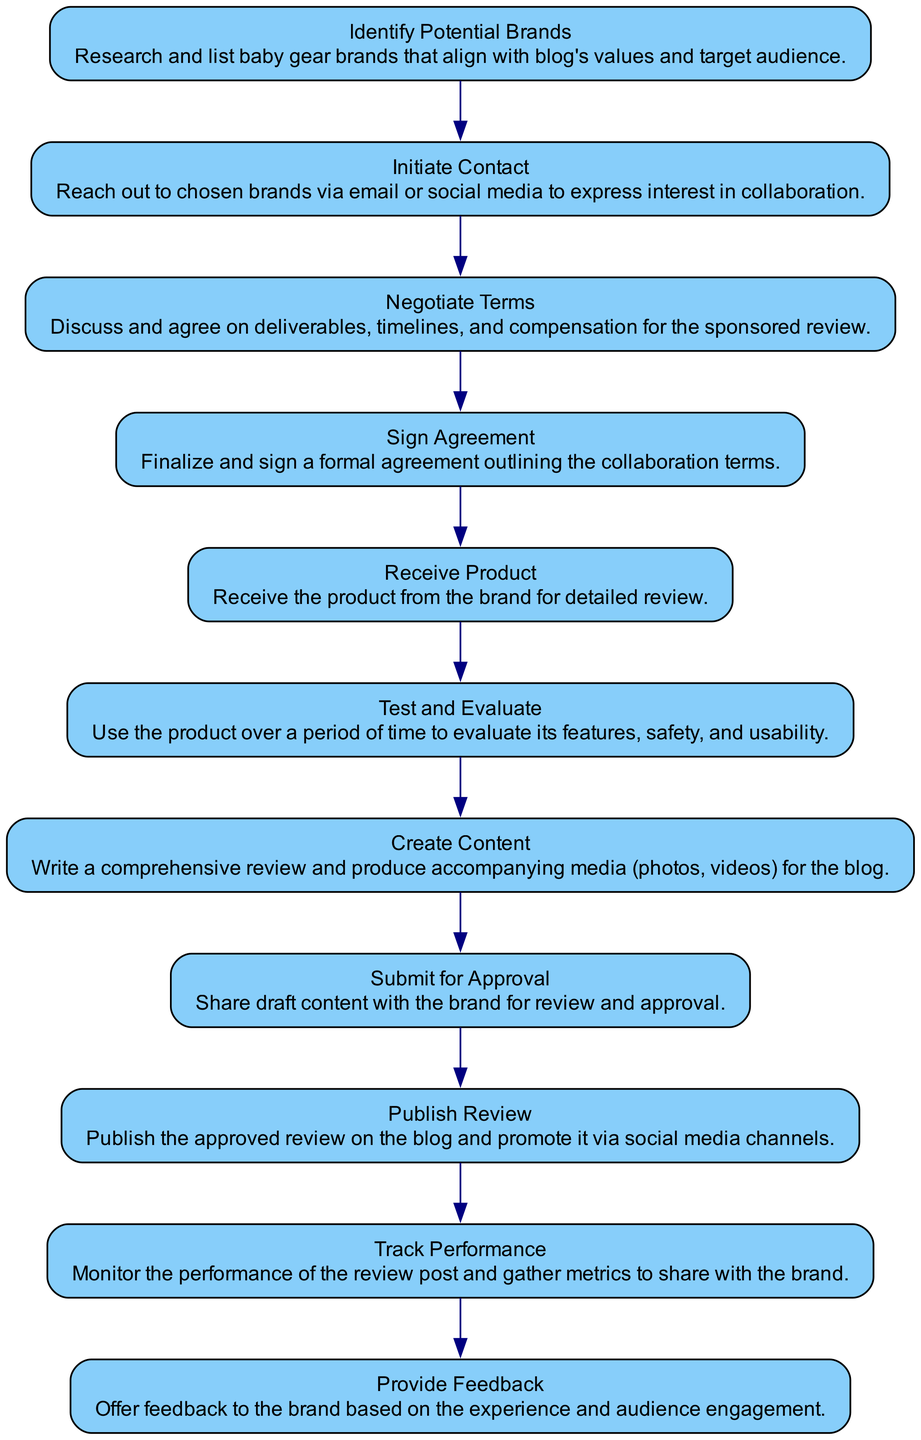What is the first activity in the process? The first activity is the one that has no incoming transitions. By looking at the diagram, we see that "Identify Potential Brands" is the starting point, as it is the first node listed and has no incoming arrows.
Answer: Identify Potential Brands How many activities are in the process? To determine the total number of activities, I count the listed nodes in the diagram. There are ten distinct activities present in this activity diagram.
Answer: 10 What comes after "Negotiate Terms"? To identify what follows "Negotiate Terms," I look for the outgoing transition from this activity. The next specified activity after "Negotiate Terms" is "Sign Agreement."
Answer: Sign Agreement Which activity precedes "Create Content"? The activity directly before "Create Content" in the diagram according to its transitions is "Test and Evaluate," as it has an arrow pointing to "Create Content."
Answer: Test and Evaluate How many transitions are there in total? To find the total number of transitions, I count the arrows connecting the activities in the diagram. A total of ten transitions are indicated between the activities.
Answer: 10 What is the last activity in this process? The last activity is the endpoint of the flow in the diagram. Following the transitions, "Provide Feedback" is the final activity listed in the diagram.
Answer: Provide Feedback Which two activities are directly connected to "Submit for Approval"? I analyze the diagram for edges leading to and from "Submit for Approval." The activities "Create Content" (preceding) and "Publish Review" (following) are directly connected to "Submit for Approval."
Answer: Create Content, Publish Review In which step do you negotiate deliverables and timelines? I search for the specific activity that describes the discussion of deliverables and timelines. According to the diagram, this occurs in the "Negotiate Terms" step.
Answer: Negotiate Terms What activity follows the phase of receiving the product? By identifying the outgoing transition from the "Receive Product" activity, the next step in the process is "Test and Evaluate."
Answer: Test and Evaluate 